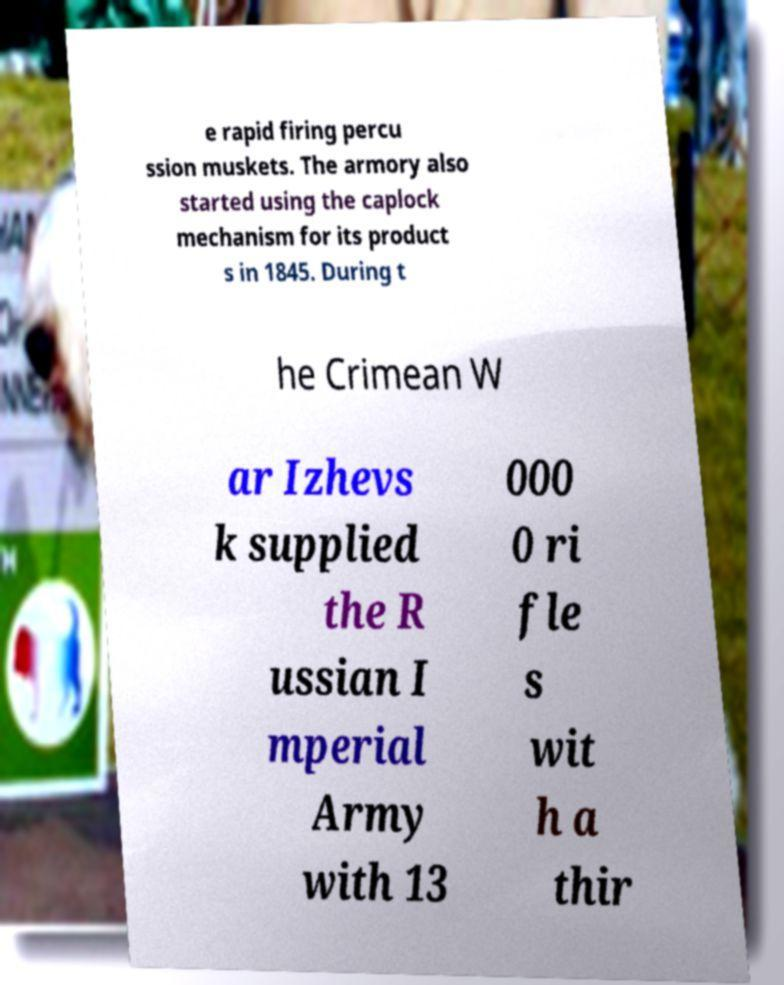Please identify and transcribe the text found in this image. e rapid firing percu ssion muskets. The armory also started using the caplock mechanism for its product s in 1845. During t he Crimean W ar Izhevs k supplied the R ussian I mperial Army with 13 000 0 ri fle s wit h a thir 